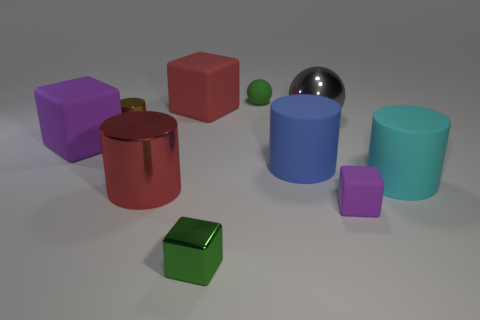Do the matte thing to the left of the large metal cylinder and the tiny matte block have the same color?
Give a very brief answer. Yes. What material is the large blue object that is the same shape as the tiny brown object?
Give a very brief answer. Rubber. How many spheres are the same size as the green block?
Your answer should be compact. 1. What shape is the large gray object?
Your answer should be very brief. Sphere. What size is the object that is to the right of the blue cylinder and on the left side of the tiny purple block?
Give a very brief answer. Large. What material is the purple block on the right side of the green rubber thing?
Make the answer very short. Rubber. Is the color of the tiny matte cube the same as the block left of the red cylinder?
Your answer should be very brief. Yes. How many things are either big objects behind the big cyan thing or big rubber objects on the left side of the green shiny block?
Make the answer very short. 4. What is the color of the small object that is both in front of the metallic ball and behind the small matte cube?
Make the answer very short. Brown. Are there more purple objects than large purple matte spheres?
Give a very brief answer. Yes. 